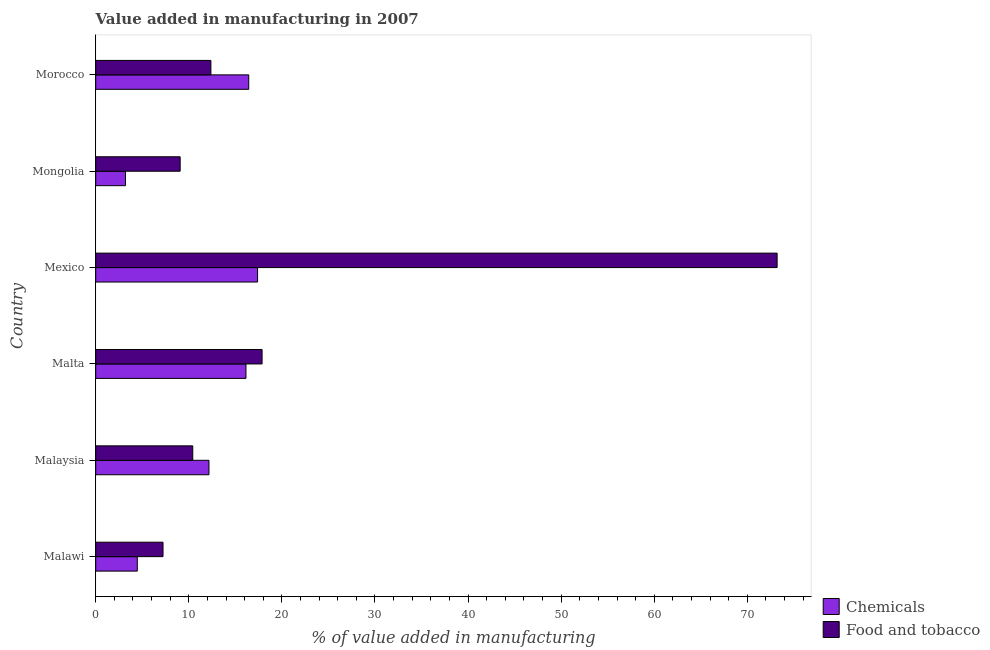Are the number of bars per tick equal to the number of legend labels?
Keep it short and to the point. Yes. How many bars are there on the 1st tick from the top?
Offer a very short reply. 2. How many bars are there on the 2nd tick from the bottom?
Ensure brevity in your answer.  2. What is the label of the 6th group of bars from the top?
Ensure brevity in your answer.  Malawi. What is the value added by manufacturing food and tobacco in Malaysia?
Ensure brevity in your answer.  10.43. Across all countries, what is the maximum value added by manufacturing food and tobacco?
Offer a terse response. 73.2. Across all countries, what is the minimum value added by  manufacturing chemicals?
Your answer should be very brief. 3.2. In which country was the value added by  manufacturing chemicals maximum?
Provide a succinct answer. Mexico. In which country was the value added by manufacturing food and tobacco minimum?
Provide a short and direct response. Malawi. What is the total value added by manufacturing food and tobacco in the graph?
Your answer should be compact. 130.17. What is the difference between the value added by  manufacturing chemicals in Malawi and that in Mongolia?
Keep it short and to the point. 1.26. What is the difference between the value added by  manufacturing chemicals in Mexico and the value added by manufacturing food and tobacco in Morocco?
Ensure brevity in your answer.  5.01. What is the average value added by  manufacturing chemicals per country?
Give a very brief answer. 11.63. What is the difference between the value added by manufacturing food and tobacco and value added by  manufacturing chemicals in Malta?
Offer a terse response. 1.73. In how many countries, is the value added by manufacturing food and tobacco greater than 58 %?
Keep it short and to the point. 1. What is the ratio of the value added by  manufacturing chemicals in Malawi to that in Mongolia?
Your answer should be very brief. 1.4. Is the value added by  manufacturing chemicals in Mexico less than that in Morocco?
Offer a terse response. No. What is the difference between the highest and the second highest value added by manufacturing food and tobacco?
Your answer should be very brief. 55.33. What is the difference between the highest and the lowest value added by  manufacturing chemicals?
Keep it short and to the point. 14.19. In how many countries, is the value added by  manufacturing chemicals greater than the average value added by  manufacturing chemicals taken over all countries?
Offer a terse response. 4. What does the 2nd bar from the top in Malaysia represents?
Give a very brief answer. Chemicals. What does the 2nd bar from the bottom in Mongolia represents?
Provide a succinct answer. Food and tobacco. What is the difference between two consecutive major ticks on the X-axis?
Offer a very short reply. 10. Are the values on the major ticks of X-axis written in scientific E-notation?
Give a very brief answer. No. Does the graph contain any zero values?
Offer a very short reply. No. Does the graph contain grids?
Provide a short and direct response. No. How are the legend labels stacked?
Your response must be concise. Vertical. What is the title of the graph?
Give a very brief answer. Value added in manufacturing in 2007. Does "Exports" appear as one of the legend labels in the graph?
Your response must be concise. No. What is the label or title of the X-axis?
Offer a terse response. % of value added in manufacturing. What is the label or title of the Y-axis?
Your response must be concise. Country. What is the % of value added in manufacturing in Chemicals in Malawi?
Provide a succinct answer. 4.47. What is the % of value added in manufacturing in Food and tobacco in Malawi?
Provide a short and direct response. 7.23. What is the % of value added in manufacturing in Chemicals in Malaysia?
Your response must be concise. 12.17. What is the % of value added in manufacturing of Food and tobacco in Malaysia?
Give a very brief answer. 10.43. What is the % of value added in manufacturing in Chemicals in Malta?
Ensure brevity in your answer.  16.14. What is the % of value added in manufacturing of Food and tobacco in Malta?
Your answer should be compact. 17.87. What is the % of value added in manufacturing of Chemicals in Mexico?
Make the answer very short. 17.39. What is the % of value added in manufacturing of Food and tobacco in Mexico?
Your response must be concise. 73.2. What is the % of value added in manufacturing in Chemicals in Mongolia?
Ensure brevity in your answer.  3.2. What is the % of value added in manufacturing in Food and tobacco in Mongolia?
Your response must be concise. 9.07. What is the % of value added in manufacturing of Chemicals in Morocco?
Ensure brevity in your answer.  16.44. What is the % of value added in manufacturing of Food and tobacco in Morocco?
Your answer should be compact. 12.37. Across all countries, what is the maximum % of value added in manufacturing of Chemicals?
Offer a terse response. 17.39. Across all countries, what is the maximum % of value added in manufacturing in Food and tobacco?
Provide a short and direct response. 73.2. Across all countries, what is the minimum % of value added in manufacturing of Chemicals?
Make the answer very short. 3.2. Across all countries, what is the minimum % of value added in manufacturing of Food and tobacco?
Offer a terse response. 7.23. What is the total % of value added in manufacturing in Chemicals in the graph?
Keep it short and to the point. 69.8. What is the total % of value added in manufacturing in Food and tobacco in the graph?
Offer a terse response. 130.17. What is the difference between the % of value added in manufacturing of Chemicals in Malawi and that in Malaysia?
Give a very brief answer. -7.7. What is the difference between the % of value added in manufacturing of Food and tobacco in Malawi and that in Malaysia?
Your answer should be compact. -3.2. What is the difference between the % of value added in manufacturing in Chemicals in Malawi and that in Malta?
Provide a short and direct response. -11.67. What is the difference between the % of value added in manufacturing in Food and tobacco in Malawi and that in Malta?
Offer a very short reply. -10.64. What is the difference between the % of value added in manufacturing of Chemicals in Malawi and that in Mexico?
Provide a succinct answer. -12.92. What is the difference between the % of value added in manufacturing in Food and tobacco in Malawi and that in Mexico?
Provide a short and direct response. -65.97. What is the difference between the % of value added in manufacturing in Chemicals in Malawi and that in Mongolia?
Provide a succinct answer. 1.26. What is the difference between the % of value added in manufacturing in Food and tobacco in Malawi and that in Mongolia?
Provide a short and direct response. -1.84. What is the difference between the % of value added in manufacturing in Chemicals in Malawi and that in Morocco?
Your response must be concise. -11.97. What is the difference between the % of value added in manufacturing in Food and tobacco in Malawi and that in Morocco?
Ensure brevity in your answer.  -5.14. What is the difference between the % of value added in manufacturing of Chemicals in Malaysia and that in Malta?
Make the answer very short. -3.98. What is the difference between the % of value added in manufacturing in Food and tobacco in Malaysia and that in Malta?
Your answer should be very brief. -7.45. What is the difference between the % of value added in manufacturing in Chemicals in Malaysia and that in Mexico?
Provide a succinct answer. -5.22. What is the difference between the % of value added in manufacturing of Food and tobacco in Malaysia and that in Mexico?
Ensure brevity in your answer.  -62.77. What is the difference between the % of value added in manufacturing of Chemicals in Malaysia and that in Mongolia?
Offer a terse response. 8.96. What is the difference between the % of value added in manufacturing of Food and tobacco in Malaysia and that in Mongolia?
Offer a very short reply. 1.35. What is the difference between the % of value added in manufacturing of Chemicals in Malaysia and that in Morocco?
Make the answer very short. -4.27. What is the difference between the % of value added in manufacturing in Food and tobacco in Malaysia and that in Morocco?
Keep it short and to the point. -1.95. What is the difference between the % of value added in manufacturing of Chemicals in Malta and that in Mexico?
Your answer should be compact. -1.25. What is the difference between the % of value added in manufacturing in Food and tobacco in Malta and that in Mexico?
Give a very brief answer. -55.33. What is the difference between the % of value added in manufacturing in Chemicals in Malta and that in Mongolia?
Your answer should be very brief. 12.94. What is the difference between the % of value added in manufacturing in Food and tobacco in Malta and that in Mongolia?
Provide a succinct answer. 8.8. What is the difference between the % of value added in manufacturing of Chemicals in Malta and that in Morocco?
Offer a very short reply. -0.3. What is the difference between the % of value added in manufacturing in Food and tobacco in Malta and that in Morocco?
Ensure brevity in your answer.  5.5. What is the difference between the % of value added in manufacturing of Chemicals in Mexico and that in Mongolia?
Provide a succinct answer. 14.19. What is the difference between the % of value added in manufacturing in Food and tobacco in Mexico and that in Mongolia?
Keep it short and to the point. 64.13. What is the difference between the % of value added in manufacturing in Chemicals in Mexico and that in Morocco?
Your answer should be compact. 0.95. What is the difference between the % of value added in manufacturing in Food and tobacco in Mexico and that in Morocco?
Ensure brevity in your answer.  60.83. What is the difference between the % of value added in manufacturing of Chemicals in Mongolia and that in Morocco?
Your response must be concise. -13.24. What is the difference between the % of value added in manufacturing of Food and tobacco in Mongolia and that in Morocco?
Keep it short and to the point. -3.3. What is the difference between the % of value added in manufacturing in Chemicals in Malawi and the % of value added in manufacturing in Food and tobacco in Malaysia?
Provide a succinct answer. -5.96. What is the difference between the % of value added in manufacturing of Chemicals in Malawi and the % of value added in manufacturing of Food and tobacco in Malta?
Provide a short and direct response. -13.4. What is the difference between the % of value added in manufacturing in Chemicals in Malawi and the % of value added in manufacturing in Food and tobacco in Mexico?
Your response must be concise. -68.73. What is the difference between the % of value added in manufacturing in Chemicals in Malawi and the % of value added in manufacturing in Food and tobacco in Mongolia?
Give a very brief answer. -4.6. What is the difference between the % of value added in manufacturing in Chemicals in Malawi and the % of value added in manufacturing in Food and tobacco in Morocco?
Offer a very short reply. -7.91. What is the difference between the % of value added in manufacturing in Chemicals in Malaysia and the % of value added in manufacturing in Food and tobacco in Malta?
Offer a terse response. -5.71. What is the difference between the % of value added in manufacturing in Chemicals in Malaysia and the % of value added in manufacturing in Food and tobacco in Mexico?
Ensure brevity in your answer.  -61.03. What is the difference between the % of value added in manufacturing in Chemicals in Malaysia and the % of value added in manufacturing in Food and tobacco in Mongolia?
Keep it short and to the point. 3.09. What is the difference between the % of value added in manufacturing in Chemicals in Malaysia and the % of value added in manufacturing in Food and tobacco in Morocco?
Provide a short and direct response. -0.21. What is the difference between the % of value added in manufacturing of Chemicals in Malta and the % of value added in manufacturing of Food and tobacco in Mexico?
Offer a terse response. -57.06. What is the difference between the % of value added in manufacturing in Chemicals in Malta and the % of value added in manufacturing in Food and tobacco in Mongolia?
Your response must be concise. 7.07. What is the difference between the % of value added in manufacturing of Chemicals in Malta and the % of value added in manufacturing of Food and tobacco in Morocco?
Ensure brevity in your answer.  3.77. What is the difference between the % of value added in manufacturing of Chemicals in Mexico and the % of value added in manufacturing of Food and tobacco in Mongolia?
Ensure brevity in your answer.  8.32. What is the difference between the % of value added in manufacturing of Chemicals in Mexico and the % of value added in manufacturing of Food and tobacco in Morocco?
Give a very brief answer. 5.01. What is the difference between the % of value added in manufacturing in Chemicals in Mongolia and the % of value added in manufacturing in Food and tobacco in Morocco?
Provide a short and direct response. -9.17. What is the average % of value added in manufacturing of Chemicals per country?
Ensure brevity in your answer.  11.63. What is the average % of value added in manufacturing of Food and tobacco per country?
Provide a succinct answer. 21.7. What is the difference between the % of value added in manufacturing of Chemicals and % of value added in manufacturing of Food and tobacco in Malawi?
Provide a short and direct response. -2.76. What is the difference between the % of value added in manufacturing in Chemicals and % of value added in manufacturing in Food and tobacco in Malaysia?
Make the answer very short. 1.74. What is the difference between the % of value added in manufacturing in Chemicals and % of value added in manufacturing in Food and tobacco in Malta?
Keep it short and to the point. -1.73. What is the difference between the % of value added in manufacturing of Chemicals and % of value added in manufacturing of Food and tobacco in Mexico?
Give a very brief answer. -55.81. What is the difference between the % of value added in manufacturing in Chemicals and % of value added in manufacturing in Food and tobacco in Mongolia?
Keep it short and to the point. -5.87. What is the difference between the % of value added in manufacturing in Chemicals and % of value added in manufacturing in Food and tobacco in Morocco?
Offer a terse response. 4.06. What is the ratio of the % of value added in manufacturing of Chemicals in Malawi to that in Malaysia?
Keep it short and to the point. 0.37. What is the ratio of the % of value added in manufacturing of Food and tobacco in Malawi to that in Malaysia?
Offer a terse response. 0.69. What is the ratio of the % of value added in manufacturing of Chemicals in Malawi to that in Malta?
Keep it short and to the point. 0.28. What is the ratio of the % of value added in manufacturing of Food and tobacco in Malawi to that in Malta?
Provide a short and direct response. 0.4. What is the ratio of the % of value added in manufacturing of Chemicals in Malawi to that in Mexico?
Keep it short and to the point. 0.26. What is the ratio of the % of value added in manufacturing of Food and tobacco in Malawi to that in Mexico?
Provide a short and direct response. 0.1. What is the ratio of the % of value added in manufacturing in Chemicals in Malawi to that in Mongolia?
Your answer should be very brief. 1.4. What is the ratio of the % of value added in manufacturing of Food and tobacco in Malawi to that in Mongolia?
Offer a very short reply. 0.8. What is the ratio of the % of value added in manufacturing in Chemicals in Malawi to that in Morocco?
Ensure brevity in your answer.  0.27. What is the ratio of the % of value added in manufacturing in Food and tobacco in Malawi to that in Morocco?
Provide a short and direct response. 0.58. What is the ratio of the % of value added in manufacturing in Chemicals in Malaysia to that in Malta?
Make the answer very short. 0.75. What is the ratio of the % of value added in manufacturing in Food and tobacco in Malaysia to that in Malta?
Your response must be concise. 0.58. What is the ratio of the % of value added in manufacturing in Chemicals in Malaysia to that in Mexico?
Your answer should be compact. 0.7. What is the ratio of the % of value added in manufacturing of Food and tobacco in Malaysia to that in Mexico?
Ensure brevity in your answer.  0.14. What is the ratio of the % of value added in manufacturing of Chemicals in Malaysia to that in Mongolia?
Ensure brevity in your answer.  3.8. What is the ratio of the % of value added in manufacturing in Food and tobacco in Malaysia to that in Mongolia?
Offer a terse response. 1.15. What is the ratio of the % of value added in manufacturing in Chemicals in Malaysia to that in Morocco?
Offer a terse response. 0.74. What is the ratio of the % of value added in manufacturing in Food and tobacco in Malaysia to that in Morocco?
Your answer should be compact. 0.84. What is the ratio of the % of value added in manufacturing in Chemicals in Malta to that in Mexico?
Keep it short and to the point. 0.93. What is the ratio of the % of value added in manufacturing in Food and tobacco in Malta to that in Mexico?
Provide a succinct answer. 0.24. What is the ratio of the % of value added in manufacturing of Chemicals in Malta to that in Mongolia?
Provide a succinct answer. 5.04. What is the ratio of the % of value added in manufacturing of Food and tobacco in Malta to that in Mongolia?
Provide a succinct answer. 1.97. What is the ratio of the % of value added in manufacturing of Chemicals in Malta to that in Morocco?
Offer a very short reply. 0.98. What is the ratio of the % of value added in manufacturing in Food and tobacco in Malta to that in Morocco?
Make the answer very short. 1.44. What is the ratio of the % of value added in manufacturing in Chemicals in Mexico to that in Mongolia?
Offer a very short reply. 5.43. What is the ratio of the % of value added in manufacturing in Food and tobacco in Mexico to that in Mongolia?
Your answer should be very brief. 8.07. What is the ratio of the % of value added in manufacturing in Chemicals in Mexico to that in Morocco?
Provide a succinct answer. 1.06. What is the ratio of the % of value added in manufacturing in Food and tobacco in Mexico to that in Morocco?
Give a very brief answer. 5.92. What is the ratio of the % of value added in manufacturing in Chemicals in Mongolia to that in Morocco?
Provide a short and direct response. 0.19. What is the ratio of the % of value added in manufacturing in Food and tobacco in Mongolia to that in Morocco?
Your answer should be compact. 0.73. What is the difference between the highest and the second highest % of value added in manufacturing in Chemicals?
Your answer should be very brief. 0.95. What is the difference between the highest and the second highest % of value added in manufacturing in Food and tobacco?
Provide a short and direct response. 55.33. What is the difference between the highest and the lowest % of value added in manufacturing in Chemicals?
Your answer should be compact. 14.19. What is the difference between the highest and the lowest % of value added in manufacturing in Food and tobacco?
Provide a short and direct response. 65.97. 